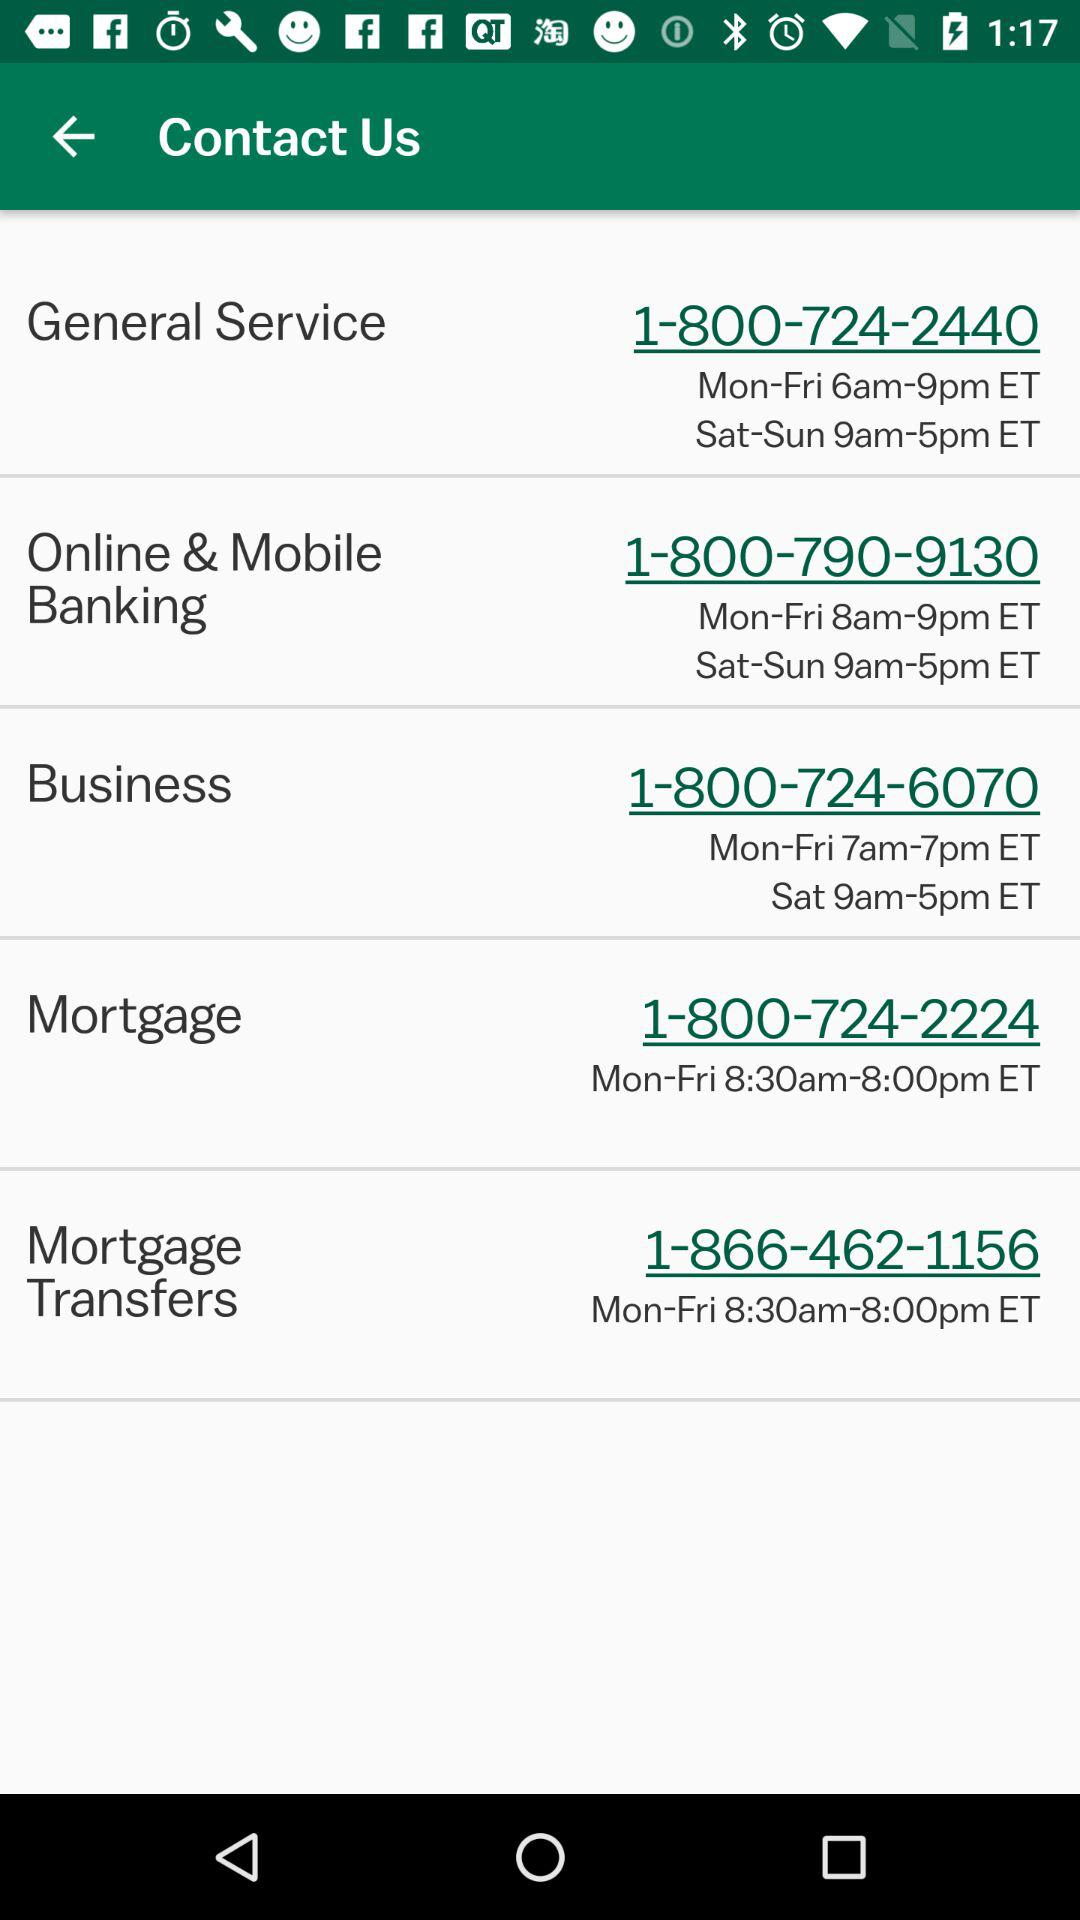What is the phone number to contact for a mortgage? The phone number to contact for a mortgage is 1-800-724-2224. 